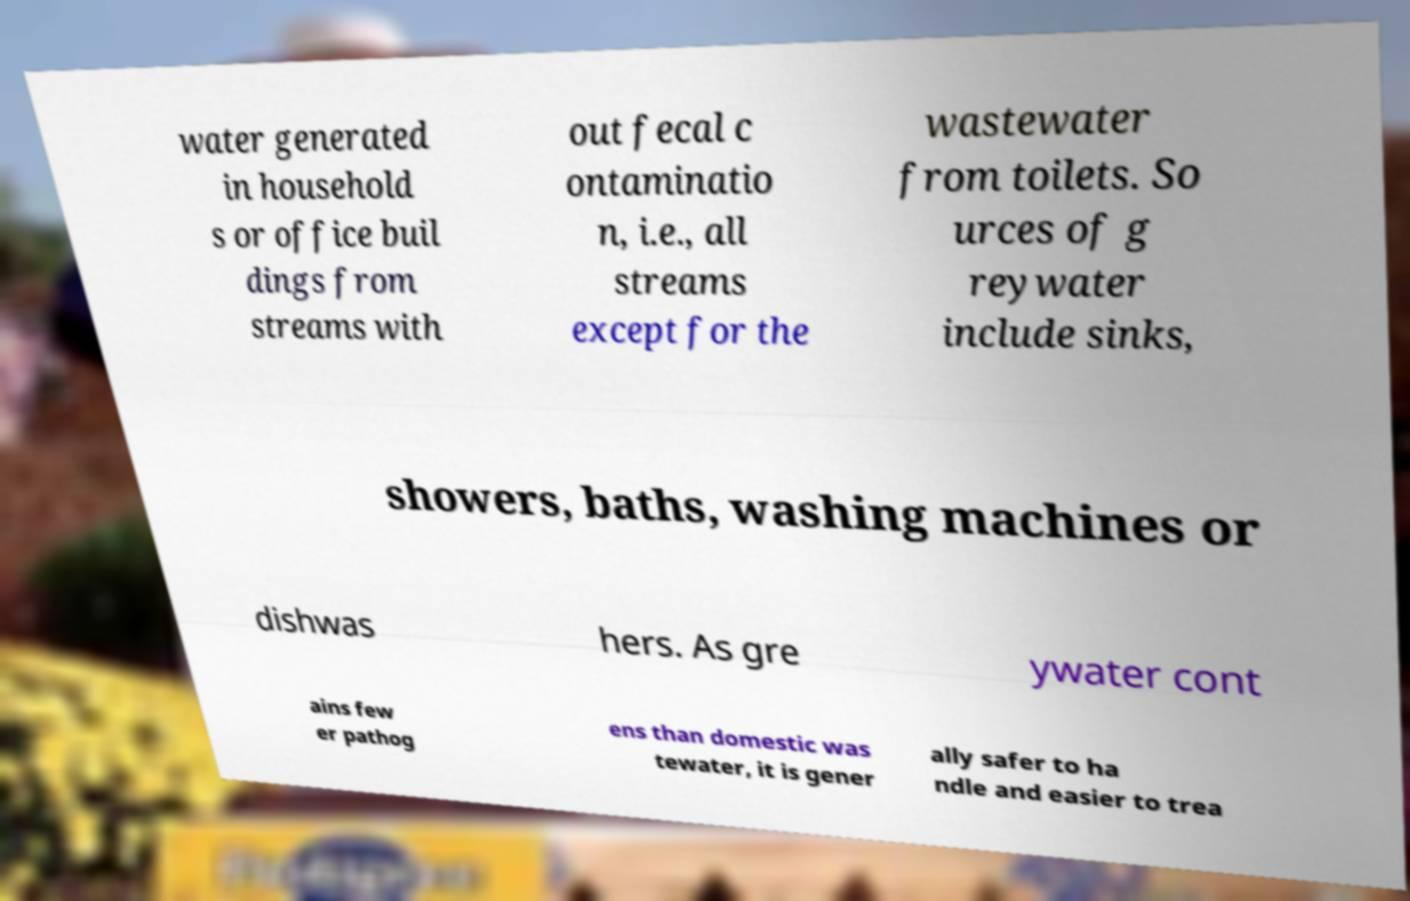What messages or text are displayed in this image? I need them in a readable, typed format. water generated in household s or office buil dings from streams with out fecal c ontaminatio n, i.e., all streams except for the wastewater from toilets. So urces of g reywater include sinks, showers, baths, washing machines or dishwas hers. As gre ywater cont ains few er pathog ens than domestic was tewater, it is gener ally safer to ha ndle and easier to trea 